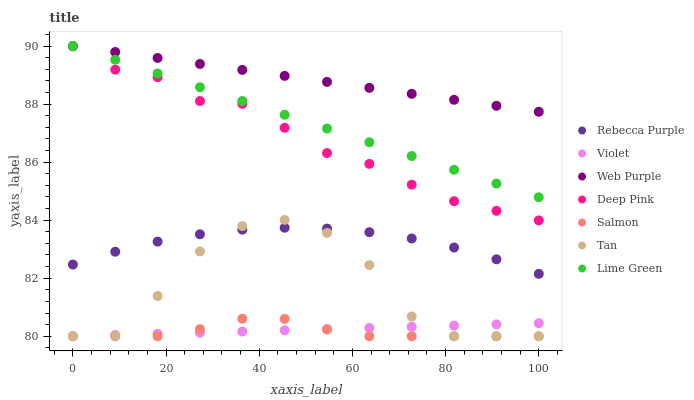Does Salmon have the minimum area under the curve?
Answer yes or no. Yes. Does Web Purple have the maximum area under the curve?
Answer yes or no. Yes. Does Web Purple have the minimum area under the curve?
Answer yes or no. No. Does Salmon have the maximum area under the curve?
Answer yes or no. No. Is Web Purple the smoothest?
Answer yes or no. Yes. Is Tan the roughest?
Answer yes or no. Yes. Is Salmon the smoothest?
Answer yes or no. No. Is Salmon the roughest?
Answer yes or no. No. Does Salmon have the lowest value?
Answer yes or no. Yes. Does Web Purple have the lowest value?
Answer yes or no. No. Does Lime Green have the highest value?
Answer yes or no. Yes. Does Salmon have the highest value?
Answer yes or no. No. Is Violet less than Deep Pink?
Answer yes or no. Yes. Is Lime Green greater than Violet?
Answer yes or no. Yes. Does Tan intersect Salmon?
Answer yes or no. Yes. Is Tan less than Salmon?
Answer yes or no. No. Is Tan greater than Salmon?
Answer yes or no. No. Does Violet intersect Deep Pink?
Answer yes or no. No. 